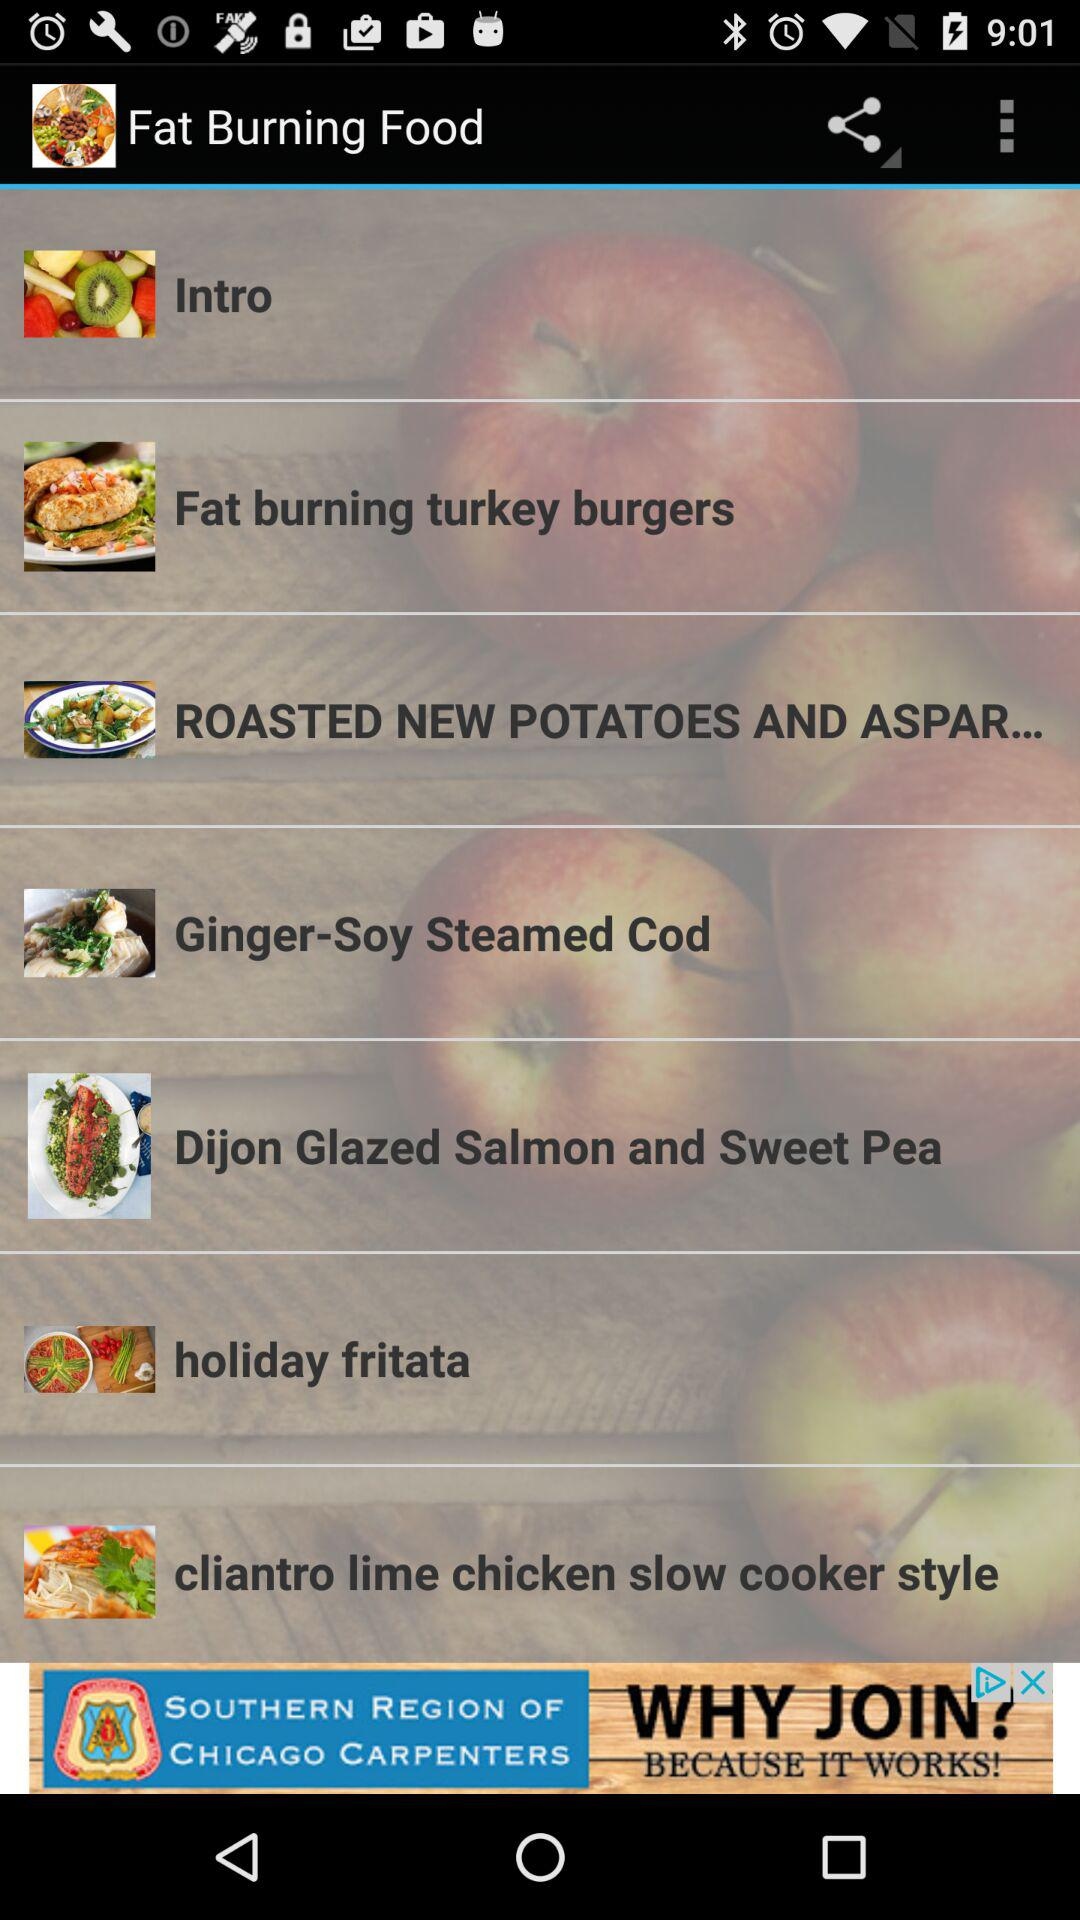How much fat does "holiday fritata" burn?
When the provided information is insufficient, respond with <no answer>. <no answer> 